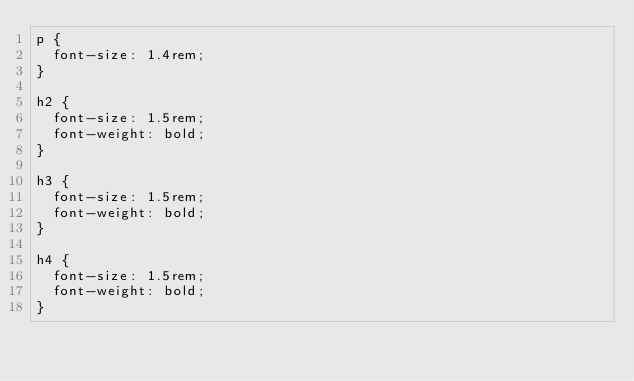<code> <loc_0><loc_0><loc_500><loc_500><_CSS_>p {
  font-size: 1.4rem;
}

h2 {
  font-size: 1.5rem;
  font-weight: bold;
}

h3 {
  font-size: 1.5rem;
  font-weight: bold;
}

h4 {
  font-size: 1.5rem;
  font-weight: bold;
}
</code> 